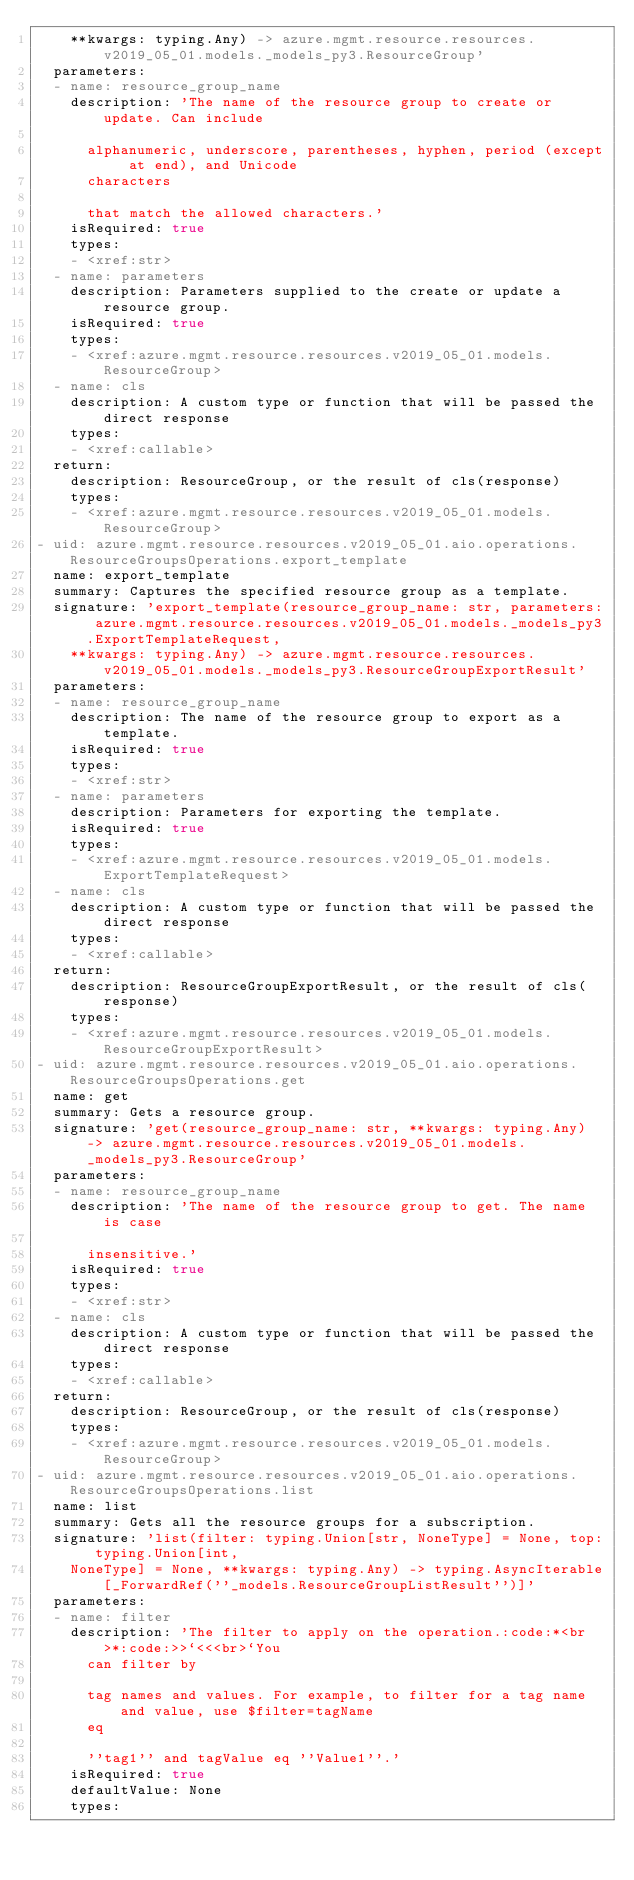Convert code to text. <code><loc_0><loc_0><loc_500><loc_500><_YAML_>    **kwargs: typing.Any) -> azure.mgmt.resource.resources.v2019_05_01.models._models_py3.ResourceGroup'
  parameters:
  - name: resource_group_name
    description: 'The name of the resource group to create or update. Can include

      alphanumeric, underscore, parentheses, hyphen, period (except at end), and Unicode
      characters

      that match the allowed characters.'
    isRequired: true
    types:
    - <xref:str>
  - name: parameters
    description: Parameters supplied to the create or update a resource group.
    isRequired: true
    types:
    - <xref:azure.mgmt.resource.resources.v2019_05_01.models.ResourceGroup>
  - name: cls
    description: A custom type or function that will be passed the direct response
    types:
    - <xref:callable>
  return:
    description: ResourceGroup, or the result of cls(response)
    types:
    - <xref:azure.mgmt.resource.resources.v2019_05_01.models.ResourceGroup>
- uid: azure.mgmt.resource.resources.v2019_05_01.aio.operations.ResourceGroupsOperations.export_template
  name: export_template
  summary: Captures the specified resource group as a template.
  signature: 'export_template(resource_group_name: str, parameters: azure.mgmt.resource.resources.v2019_05_01.models._models_py3.ExportTemplateRequest,
    **kwargs: typing.Any) -> azure.mgmt.resource.resources.v2019_05_01.models._models_py3.ResourceGroupExportResult'
  parameters:
  - name: resource_group_name
    description: The name of the resource group to export as a template.
    isRequired: true
    types:
    - <xref:str>
  - name: parameters
    description: Parameters for exporting the template.
    isRequired: true
    types:
    - <xref:azure.mgmt.resource.resources.v2019_05_01.models.ExportTemplateRequest>
  - name: cls
    description: A custom type or function that will be passed the direct response
    types:
    - <xref:callable>
  return:
    description: ResourceGroupExportResult, or the result of cls(response)
    types:
    - <xref:azure.mgmt.resource.resources.v2019_05_01.models.ResourceGroupExportResult>
- uid: azure.mgmt.resource.resources.v2019_05_01.aio.operations.ResourceGroupsOperations.get
  name: get
  summary: Gets a resource group.
  signature: 'get(resource_group_name: str, **kwargs: typing.Any) -> azure.mgmt.resource.resources.v2019_05_01.models._models_py3.ResourceGroup'
  parameters:
  - name: resource_group_name
    description: 'The name of the resource group to get. The name is case

      insensitive.'
    isRequired: true
    types:
    - <xref:str>
  - name: cls
    description: A custom type or function that will be passed the direct response
    types:
    - <xref:callable>
  return:
    description: ResourceGroup, or the result of cls(response)
    types:
    - <xref:azure.mgmt.resource.resources.v2019_05_01.models.ResourceGroup>
- uid: azure.mgmt.resource.resources.v2019_05_01.aio.operations.ResourceGroupsOperations.list
  name: list
  summary: Gets all the resource groups for a subscription.
  signature: 'list(filter: typing.Union[str, NoneType] = None, top: typing.Union[int,
    NoneType] = None, **kwargs: typing.Any) -> typing.AsyncIterable[_ForwardRef(''_models.ResourceGroupListResult'')]'
  parameters:
  - name: filter
    description: 'The filter to apply on the operation.:code:*<br>*:code:>>`<<<br>`You
      can filter by

      tag names and values. For example, to filter for a tag name and value, use $filter=tagName
      eq

      ''tag1'' and tagValue eq ''Value1''.'
    isRequired: true
    defaultValue: None
    types:</code> 